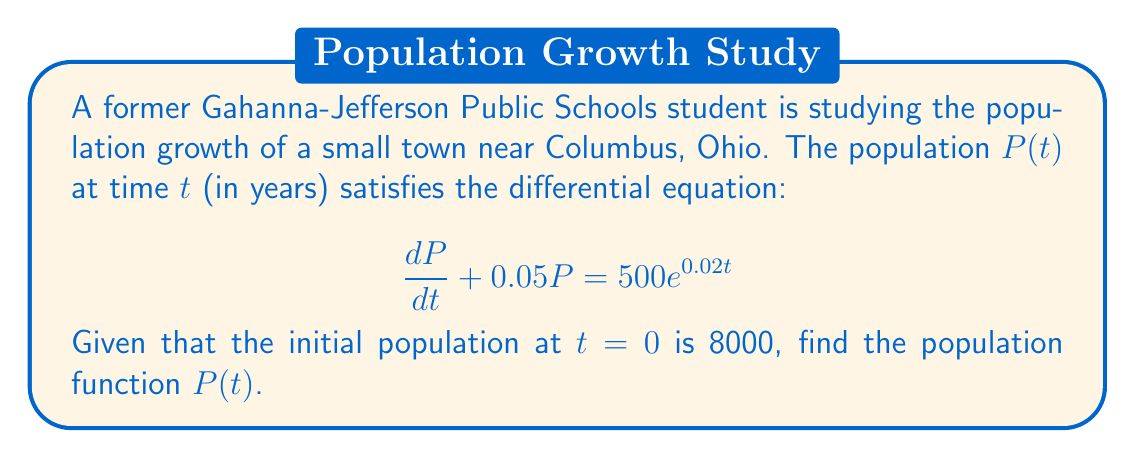Could you help me with this problem? Let's solve this first-order linear differential equation using an integrating factor:

1) The equation is in the form $\frac{dP}{dt} + a(t)P = b(t)$, where $a(t) = 0.05$ and $b(t) = 500e^{0.02t}$.

2) The integrating factor is $\mu(t) = e^{\int a(t) dt} = e^{\int 0.05 dt} = e^{0.05t}$.

3) Multiply both sides of the equation by $\mu(t)$:

   $e^{0.05t}\frac{dP}{dt} + 0.05e^{0.05t}P = 500e^{0.05t}e^{0.02t}$

4) The left side is now the derivative of $e^{0.05t}P$:

   $\frac{d}{dt}(e^{0.05t}P) = 500e^{0.07t}$

5) Integrate both sides:

   $e^{0.05t}P = \int 500e^{0.07t} dt = \frac{500}{0.07}e^{0.07t} + C$

6) Solve for $P$:

   $P = \frac{500}{0.07}e^{0.02t} + Ce^{-0.05t}$

7) Use the initial condition $P(0) = 8000$ to find $C$:

   $8000 = \frac{500}{0.07} + C$
   $C = 8000 - \frac{500}{0.07} \approx 879.29$

8) The final solution is:

   $P(t) = \frac{500}{0.07}e^{0.02t} + 879.29e^{-0.05t}$
Answer: $P(t) = \frac{500}{0.07}e^{0.02t} + 879.29e^{-0.05t}$ 